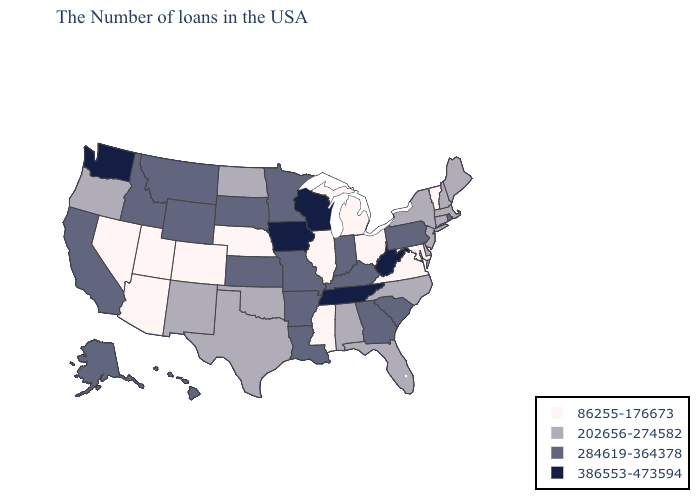Does Michigan have the lowest value in the USA?
Concise answer only. Yes. Name the states that have a value in the range 86255-176673?
Answer briefly. Vermont, Maryland, Virginia, Ohio, Michigan, Illinois, Mississippi, Nebraska, Colorado, Utah, Arizona, Nevada. Name the states that have a value in the range 386553-473594?
Be succinct. West Virginia, Tennessee, Wisconsin, Iowa, Washington. What is the highest value in the MidWest ?
Give a very brief answer. 386553-473594. What is the value of Indiana?
Be succinct. 284619-364378. What is the value of New Jersey?
Answer briefly. 202656-274582. What is the value of Rhode Island?
Be succinct. 284619-364378. Name the states that have a value in the range 386553-473594?
Keep it brief. West Virginia, Tennessee, Wisconsin, Iowa, Washington. What is the value of Illinois?
Write a very short answer. 86255-176673. Name the states that have a value in the range 86255-176673?
Give a very brief answer. Vermont, Maryland, Virginia, Ohio, Michigan, Illinois, Mississippi, Nebraska, Colorado, Utah, Arizona, Nevada. What is the value of Pennsylvania?
Short answer required. 284619-364378. Does Alaska have the highest value in the USA?
Concise answer only. No. What is the value of Missouri?
Be succinct. 284619-364378. What is the value of Pennsylvania?
Give a very brief answer. 284619-364378. Does Minnesota have the highest value in the USA?
Answer briefly. No. 